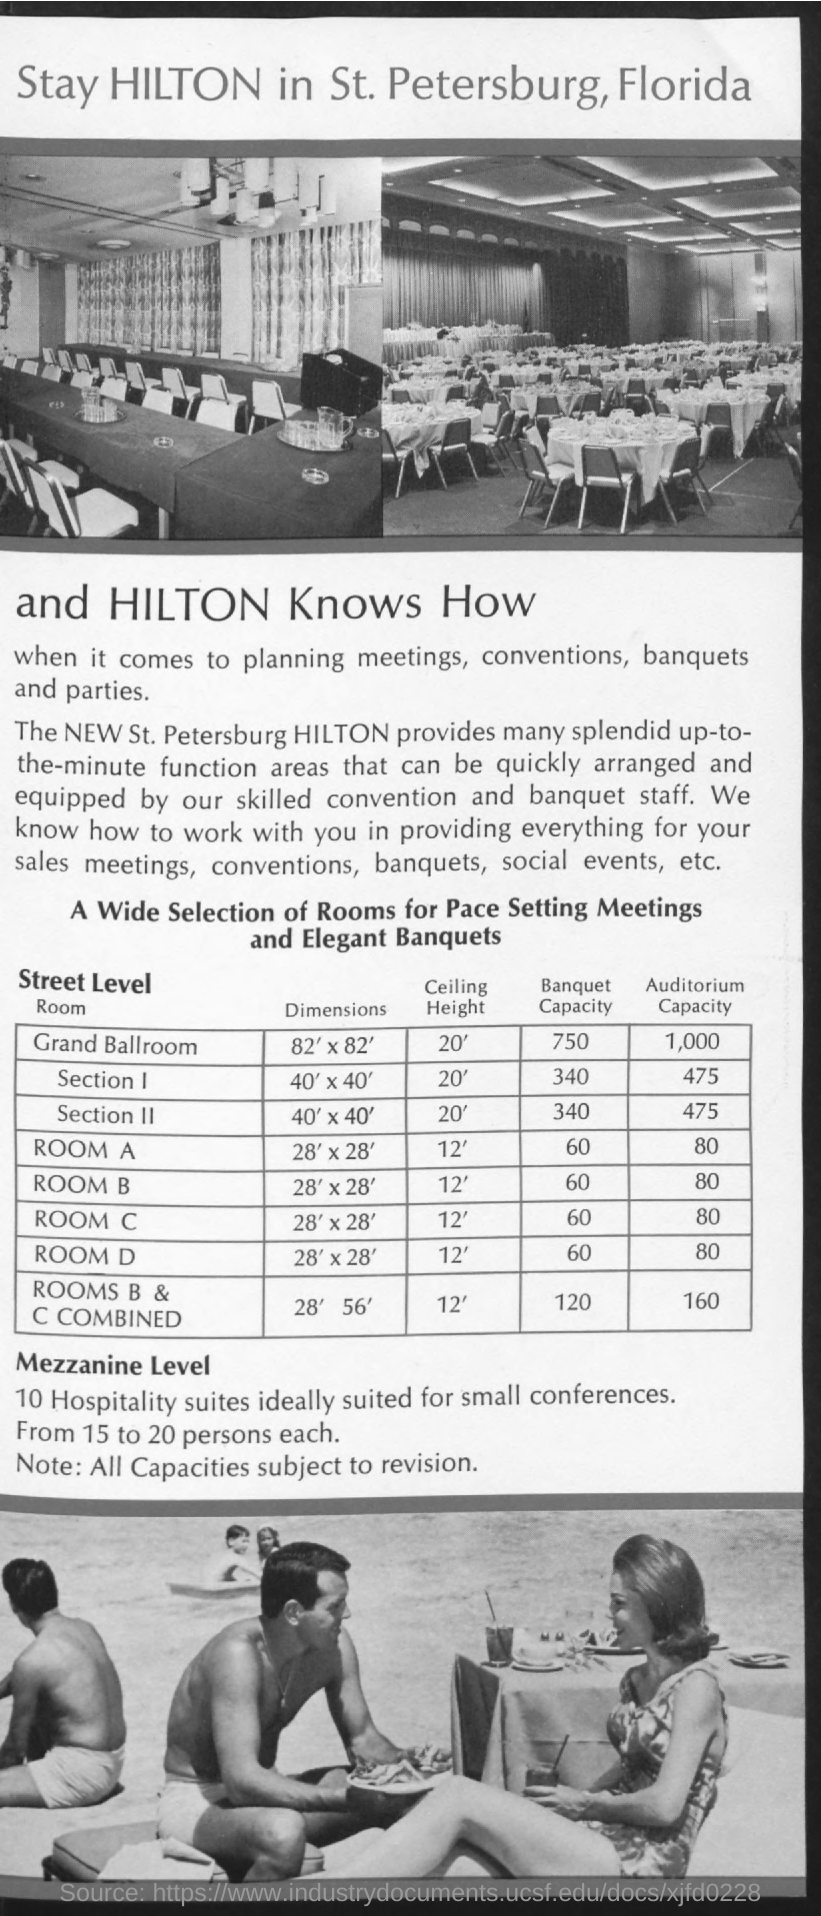What is the ceiling height of grand ballroom?
Your answer should be compact. 20'. What is the banquet capacity of grand ballroom?
Give a very brief answer. 750. What is the auditorium capacity of grand ballroom?
Offer a very short reply. 1,000. What is the ceiling height of room a?
Your response must be concise. 12'. What is the auditorium capacity of room a?
Ensure brevity in your answer.  80. What is the banquet capacity of rooms b & c combined?
Your answer should be compact. 120. 